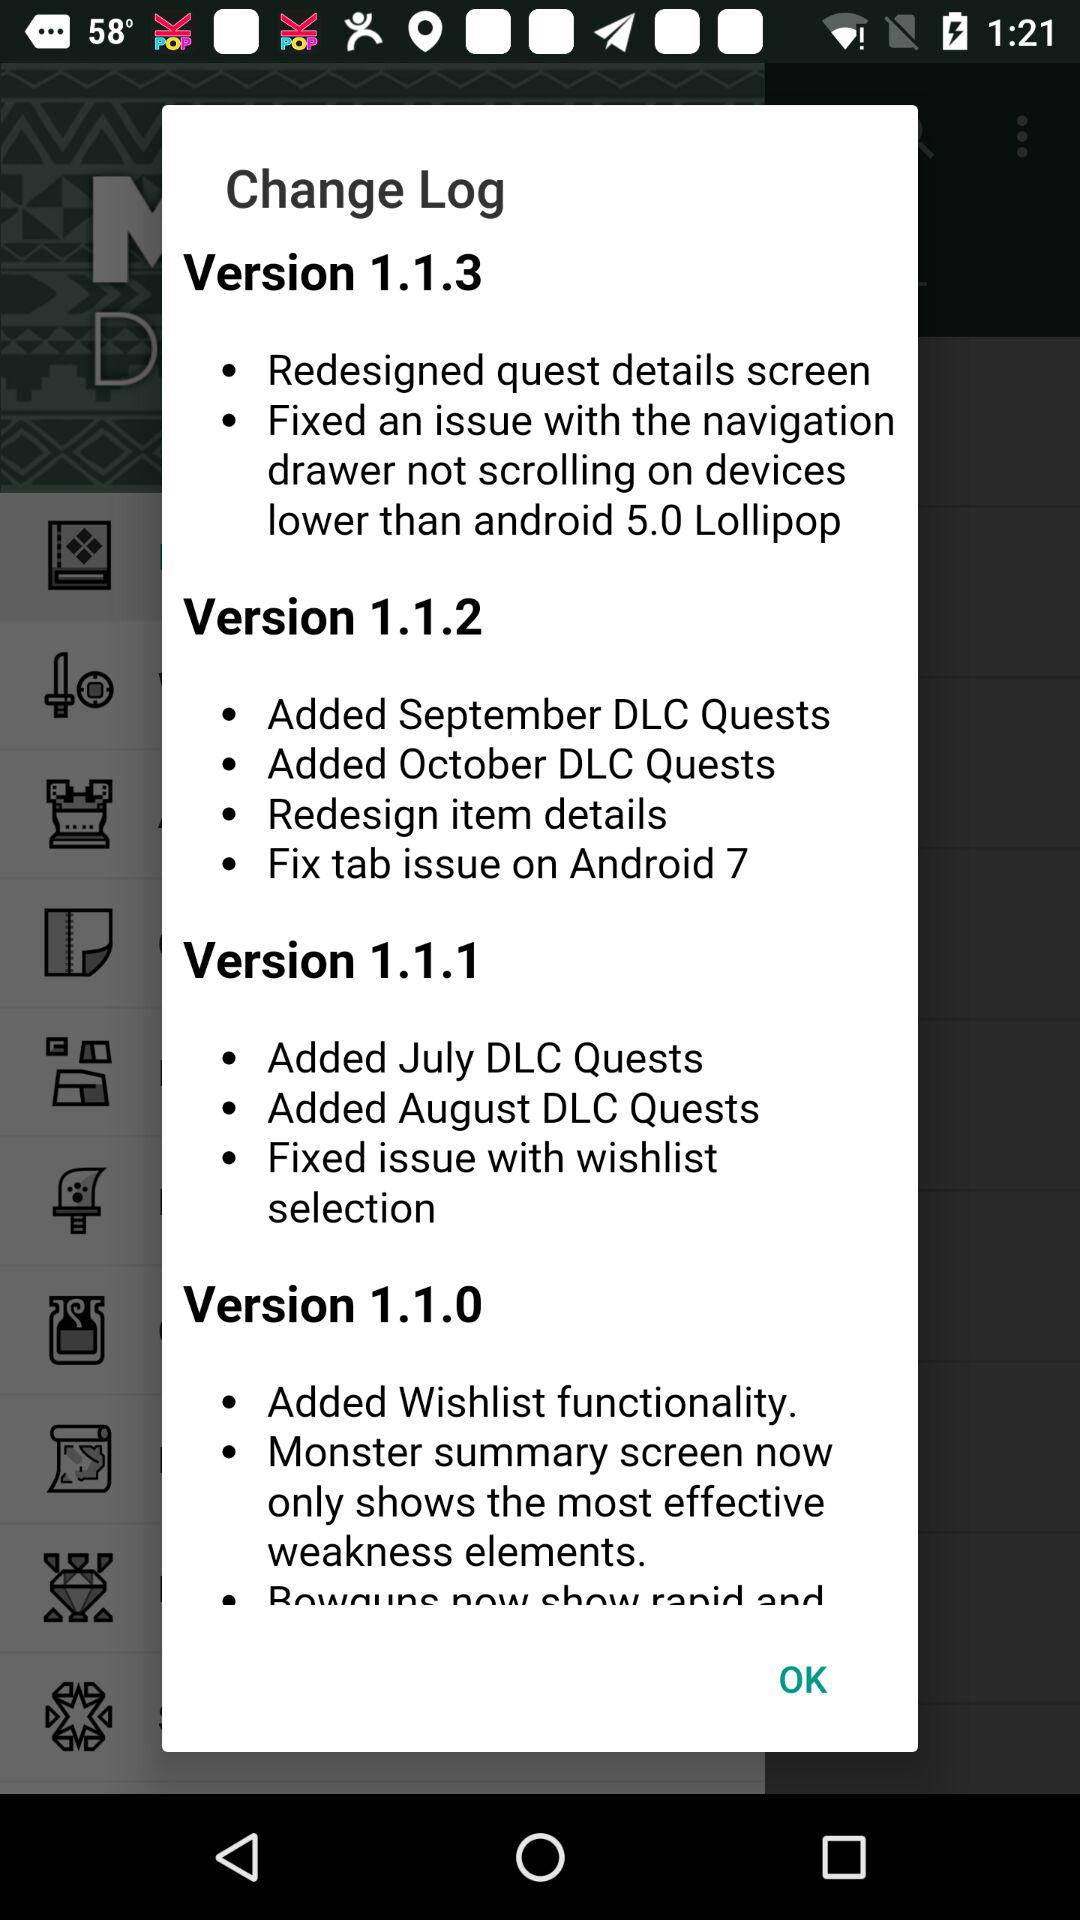What are the features in version 1.1.2? The features are "Added September DLC Quests", "Added October DLC Quests", "Redesign item details" and "Fix tab issue on Android 7". 